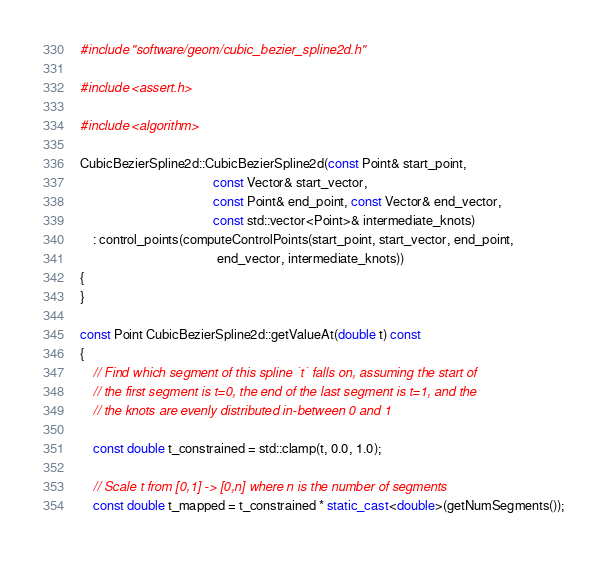<code> <loc_0><loc_0><loc_500><loc_500><_C++_>#include "software/geom/cubic_bezier_spline2d.h"

#include <assert.h>

#include <algorithm>

CubicBezierSpline2d::CubicBezierSpline2d(const Point& start_point,
                                         const Vector& start_vector,
                                         const Point& end_point, const Vector& end_vector,
                                         const std::vector<Point>& intermediate_knots)
    : control_points(computeControlPoints(start_point, start_vector, end_point,
                                          end_vector, intermediate_knots))
{
}

const Point CubicBezierSpline2d::getValueAt(double t) const
{
    // Find which segment of this spline `t` falls on, assuming the start of
    // the first segment is t=0, the end of the last segment is t=1, and the
    // the knots are evenly distributed in-between 0 and 1

    const double t_constrained = std::clamp(t, 0.0, 1.0);

    // Scale t from [0,1] -> [0,n] where n is the number of segments
    const double t_mapped = t_constrained * static_cast<double>(getNumSegments());
</code> 